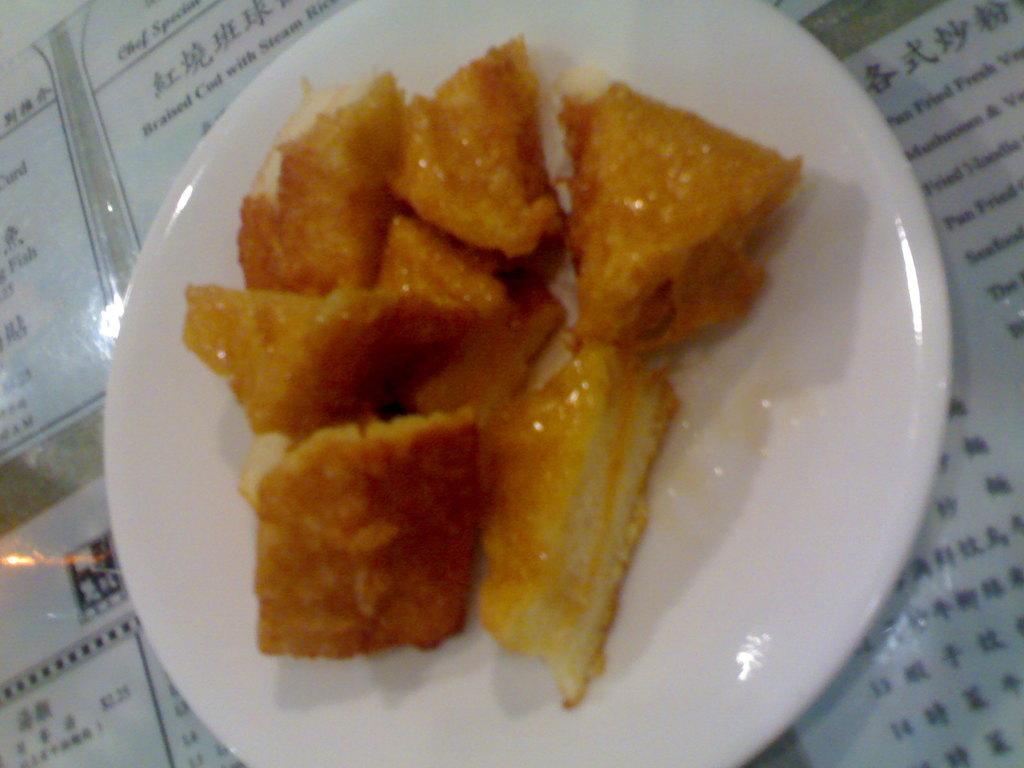Can you describe this image briefly? In this image we can see some food item on the plate and under the plate there are few objects looks like menu cards. 